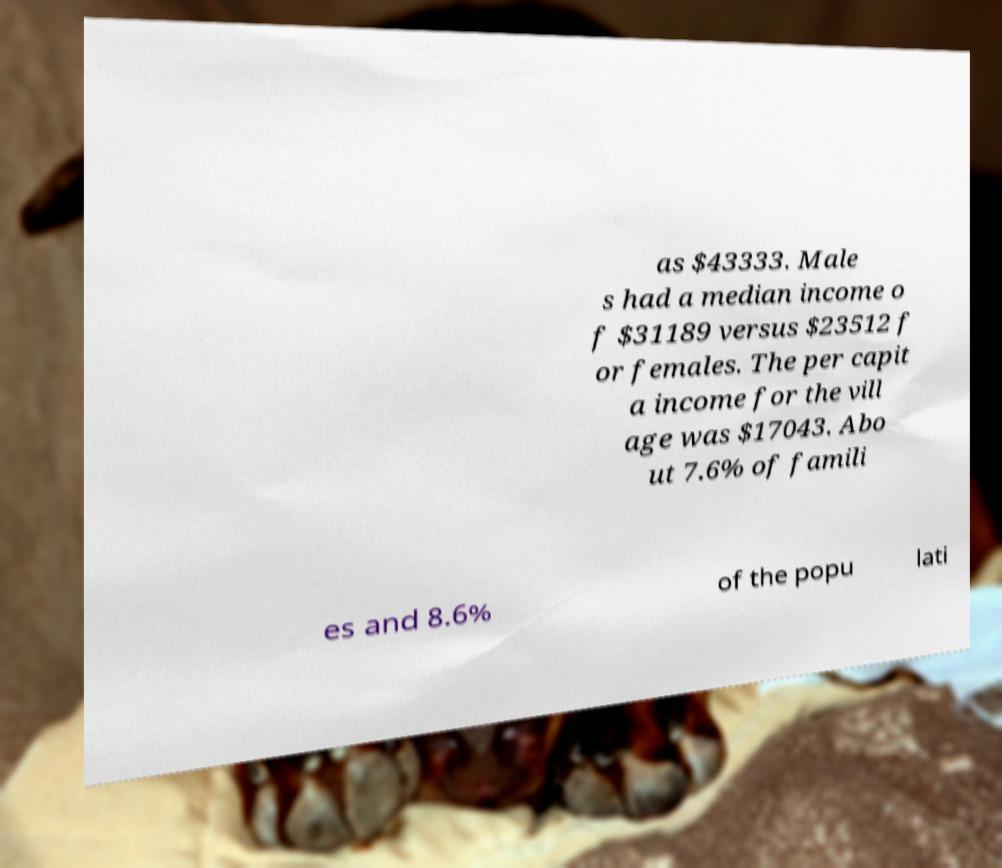Can you read and provide the text displayed in the image?This photo seems to have some interesting text. Can you extract and type it out for me? as $43333. Male s had a median income o f $31189 versus $23512 f or females. The per capit a income for the vill age was $17043. Abo ut 7.6% of famili es and 8.6% of the popu lati 